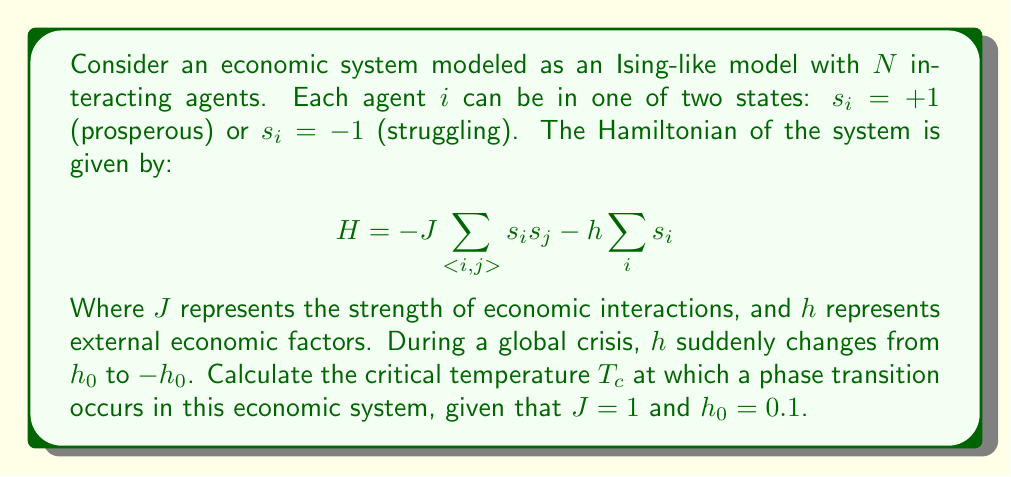Can you solve this math problem? To solve this problem, we'll follow these steps:

1) In the Ising model, the critical temperature $T_c$ is related to the interaction strength $J$ by:

   $$T_c = \frac{2J}{k_B \ln(1+\sqrt{2})}$$

   Where $k_B$ is the Boltzmann constant.

2) In our case, $J = 1$, so we can simplify:

   $$T_c = \frac{2}{k_B \ln(1+\sqrt{2})}$$

3) The Boltzmann constant $k_B$ is often set to 1 in statistical mechanics problems for simplicity. Applying this:

   $$T_c = \frac{2}{\ln(1+\sqrt{2})}$$

4) Now we can calculate:
   
   $$T_c = \frac{2}{\ln(1+\sqrt{2})} \approx 2.269$$

5) The sudden change in $h$ from $h_0$ to $-h_0$ doesn't affect the critical temperature directly in this model. However, it would shift the system's state, potentially pushing it across the phase transition boundary.

6) The ratio $h_0/T_c \approx 0.044$ is small, indicating that the external factor's influence is weak compared to the critical temperature. This suggests that the system's behavior near the phase transition is primarily driven by the interactions between agents rather than the external economic factors.
Answer: $T_c \approx 2.269$ 